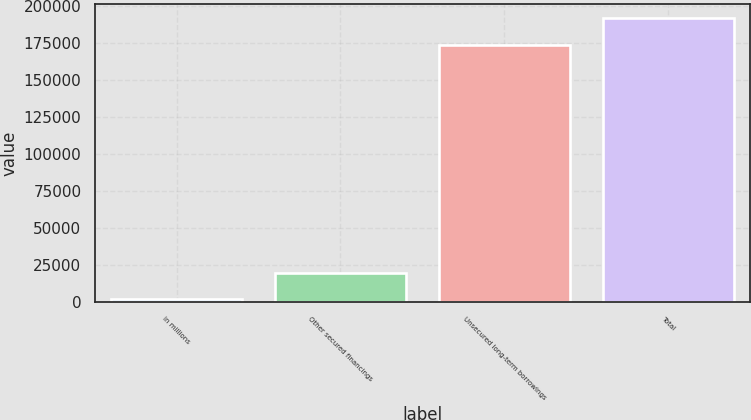Convert chart to OTSL. <chart><loc_0><loc_0><loc_500><loc_500><bar_chart><fcel>in millions<fcel>Other secured financings<fcel>Unsecured long-term borrowings<fcel>Total<nl><fcel>2011<fcel>19982.3<fcel>173545<fcel>191516<nl></chart> 